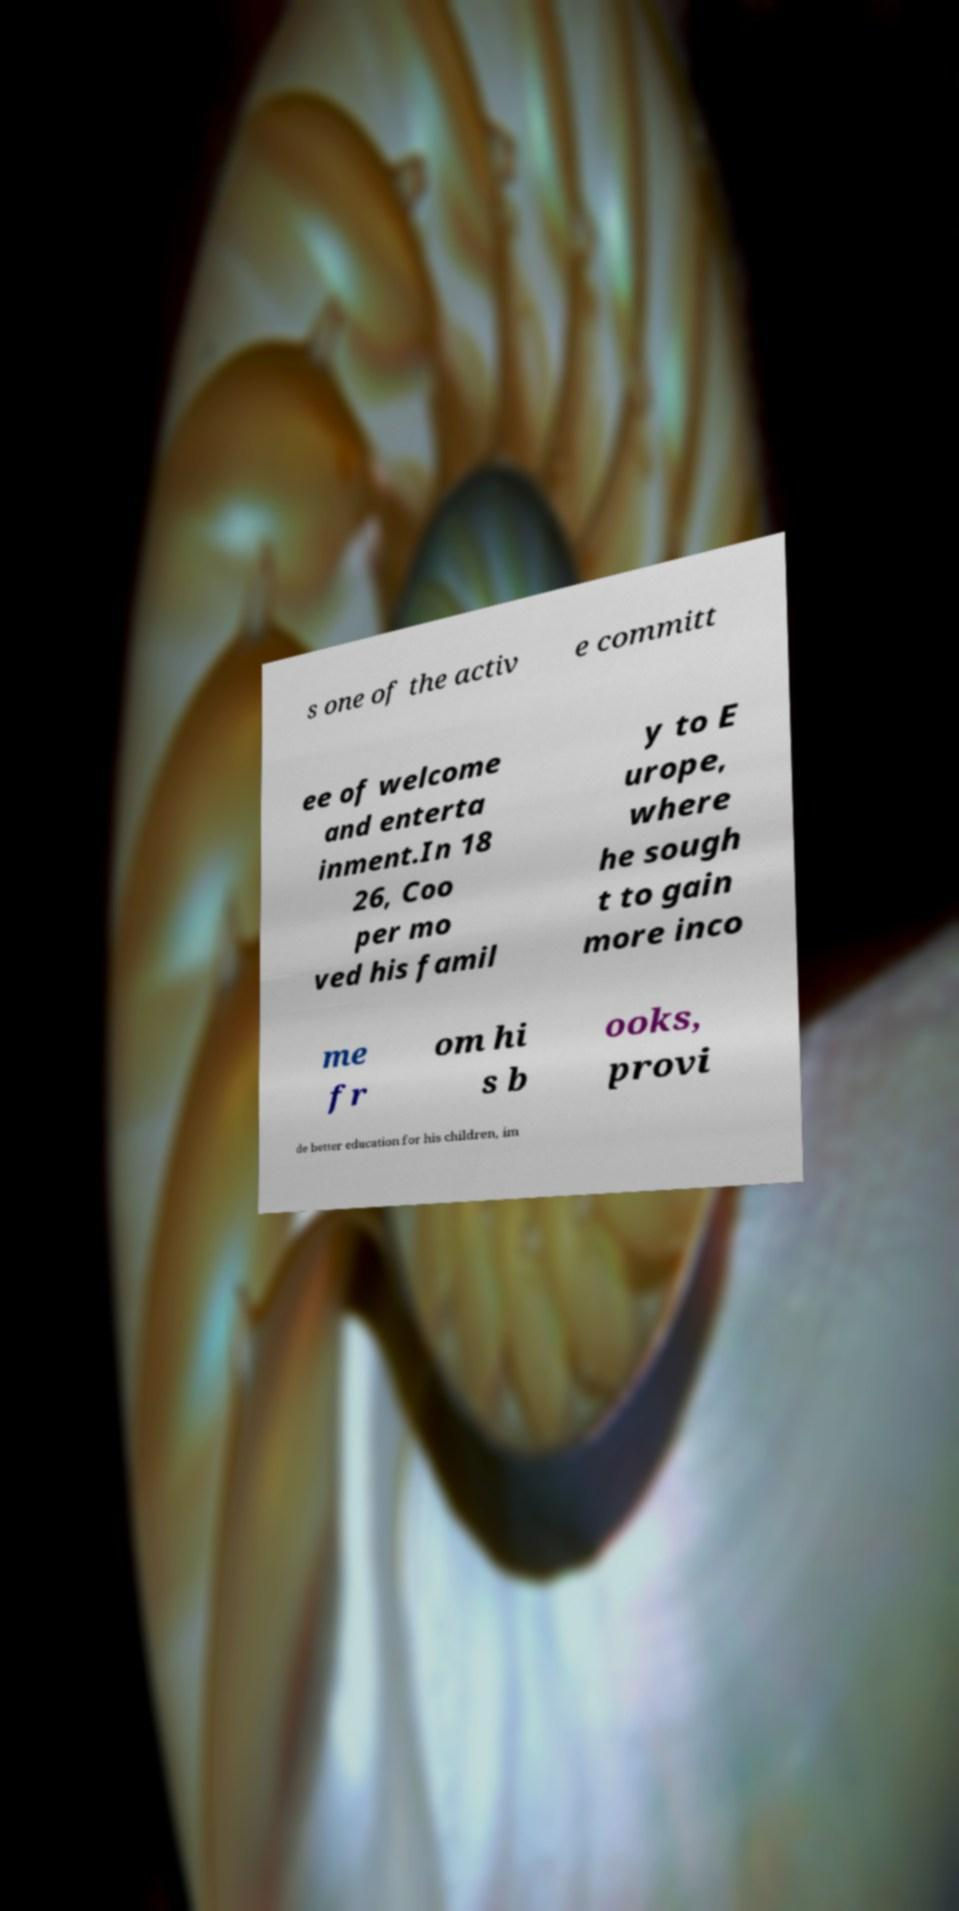Could you assist in decoding the text presented in this image and type it out clearly? s one of the activ e committ ee of welcome and enterta inment.In 18 26, Coo per mo ved his famil y to E urope, where he sough t to gain more inco me fr om hi s b ooks, provi de better education for his children, im 